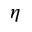<formula> <loc_0><loc_0><loc_500><loc_500>\eta</formula> 